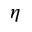<formula> <loc_0><loc_0><loc_500><loc_500>\eta</formula> 